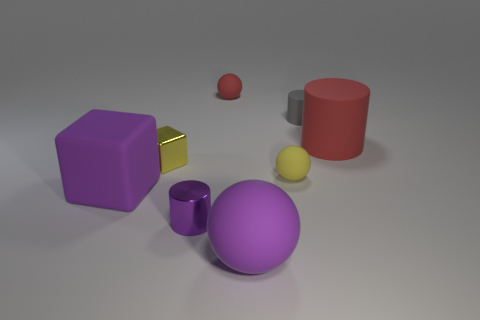Add 1 blocks. How many objects exist? 9 Subtract all spheres. How many objects are left? 5 Add 6 cylinders. How many cylinders are left? 9 Add 5 large red matte objects. How many large red matte objects exist? 6 Subtract 0 gray spheres. How many objects are left? 8 Subtract all cylinders. Subtract all tiny cylinders. How many objects are left? 3 